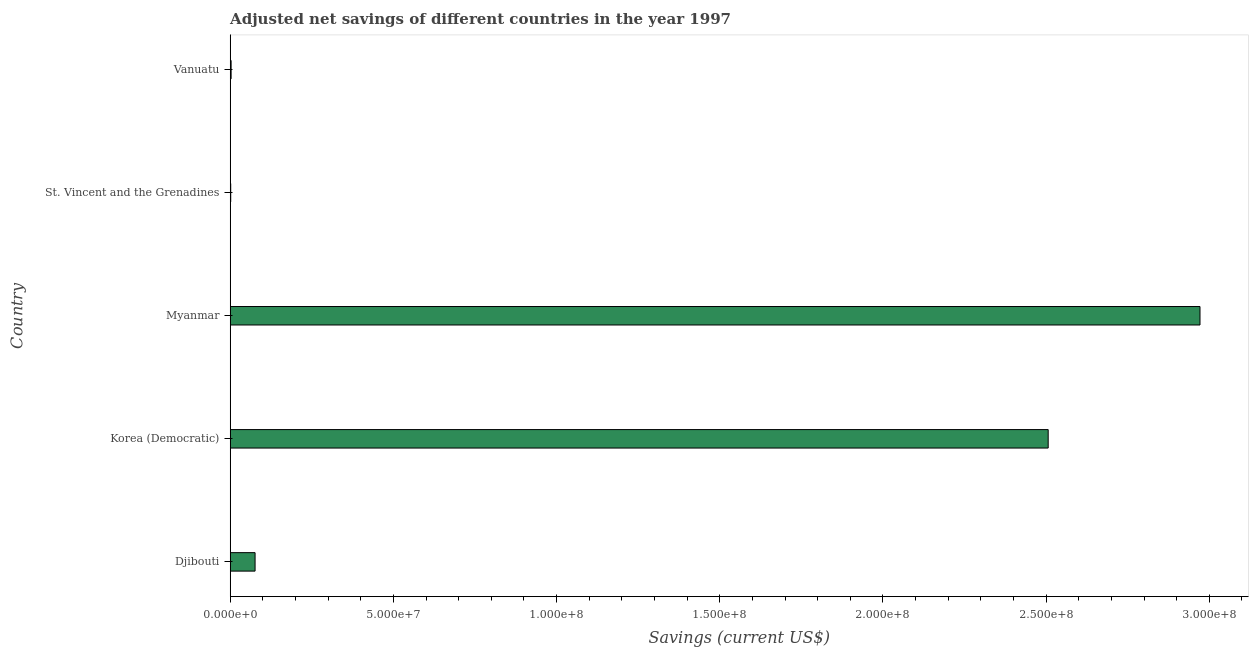What is the title of the graph?
Make the answer very short. Adjusted net savings of different countries in the year 1997. What is the label or title of the X-axis?
Provide a succinct answer. Savings (current US$). What is the label or title of the Y-axis?
Your answer should be compact. Country. What is the adjusted net savings in St. Vincent and the Grenadines?
Your response must be concise. 1.61e+05. Across all countries, what is the maximum adjusted net savings?
Provide a succinct answer. 2.97e+08. Across all countries, what is the minimum adjusted net savings?
Offer a terse response. 1.61e+05. In which country was the adjusted net savings maximum?
Make the answer very short. Myanmar. In which country was the adjusted net savings minimum?
Keep it short and to the point. St. Vincent and the Grenadines. What is the sum of the adjusted net savings?
Offer a very short reply. 5.56e+08. What is the difference between the adjusted net savings in Djibouti and Korea (Democratic)?
Offer a terse response. -2.43e+08. What is the average adjusted net savings per country?
Offer a terse response. 1.11e+08. What is the median adjusted net savings?
Offer a terse response. 7.63e+06. In how many countries, is the adjusted net savings greater than 170000000 US$?
Keep it short and to the point. 2. Is the difference between the adjusted net savings in Djibouti and Korea (Democratic) greater than the difference between any two countries?
Give a very brief answer. No. What is the difference between the highest and the second highest adjusted net savings?
Make the answer very short. 4.65e+07. Is the sum of the adjusted net savings in Myanmar and St. Vincent and the Grenadines greater than the maximum adjusted net savings across all countries?
Make the answer very short. Yes. What is the difference between the highest and the lowest adjusted net savings?
Ensure brevity in your answer.  2.97e+08. Are all the bars in the graph horizontal?
Provide a short and direct response. Yes. What is the Savings (current US$) of Djibouti?
Offer a very short reply. 7.63e+06. What is the Savings (current US$) of Korea (Democratic)?
Ensure brevity in your answer.  2.51e+08. What is the Savings (current US$) in Myanmar?
Your response must be concise. 2.97e+08. What is the Savings (current US$) in St. Vincent and the Grenadines?
Your response must be concise. 1.61e+05. What is the Savings (current US$) in Vanuatu?
Ensure brevity in your answer.  2.82e+05. What is the difference between the Savings (current US$) in Djibouti and Korea (Democratic)?
Offer a very short reply. -2.43e+08. What is the difference between the Savings (current US$) in Djibouti and Myanmar?
Give a very brief answer. -2.90e+08. What is the difference between the Savings (current US$) in Djibouti and St. Vincent and the Grenadines?
Make the answer very short. 7.46e+06. What is the difference between the Savings (current US$) in Djibouti and Vanuatu?
Provide a succinct answer. 7.34e+06. What is the difference between the Savings (current US$) in Korea (Democratic) and Myanmar?
Provide a succinct answer. -4.65e+07. What is the difference between the Savings (current US$) in Korea (Democratic) and St. Vincent and the Grenadines?
Give a very brief answer. 2.50e+08. What is the difference between the Savings (current US$) in Korea (Democratic) and Vanuatu?
Offer a terse response. 2.50e+08. What is the difference between the Savings (current US$) in Myanmar and St. Vincent and the Grenadines?
Offer a terse response. 2.97e+08. What is the difference between the Savings (current US$) in Myanmar and Vanuatu?
Your answer should be compact. 2.97e+08. What is the difference between the Savings (current US$) in St. Vincent and the Grenadines and Vanuatu?
Keep it short and to the point. -1.21e+05. What is the ratio of the Savings (current US$) in Djibouti to that in Korea (Democratic)?
Ensure brevity in your answer.  0.03. What is the ratio of the Savings (current US$) in Djibouti to that in Myanmar?
Provide a succinct answer. 0.03. What is the ratio of the Savings (current US$) in Djibouti to that in St. Vincent and the Grenadines?
Keep it short and to the point. 47.24. What is the ratio of the Savings (current US$) in Djibouti to that in Vanuatu?
Offer a very short reply. 27. What is the ratio of the Savings (current US$) in Korea (Democratic) to that in Myanmar?
Keep it short and to the point. 0.84. What is the ratio of the Savings (current US$) in Korea (Democratic) to that in St. Vincent and the Grenadines?
Give a very brief answer. 1552.92. What is the ratio of the Savings (current US$) in Korea (Democratic) to that in Vanuatu?
Provide a succinct answer. 887.42. What is the ratio of the Savings (current US$) in Myanmar to that in St. Vincent and the Grenadines?
Keep it short and to the point. 1841.14. What is the ratio of the Savings (current US$) in Myanmar to that in Vanuatu?
Ensure brevity in your answer.  1052.13. What is the ratio of the Savings (current US$) in St. Vincent and the Grenadines to that in Vanuatu?
Provide a succinct answer. 0.57. 